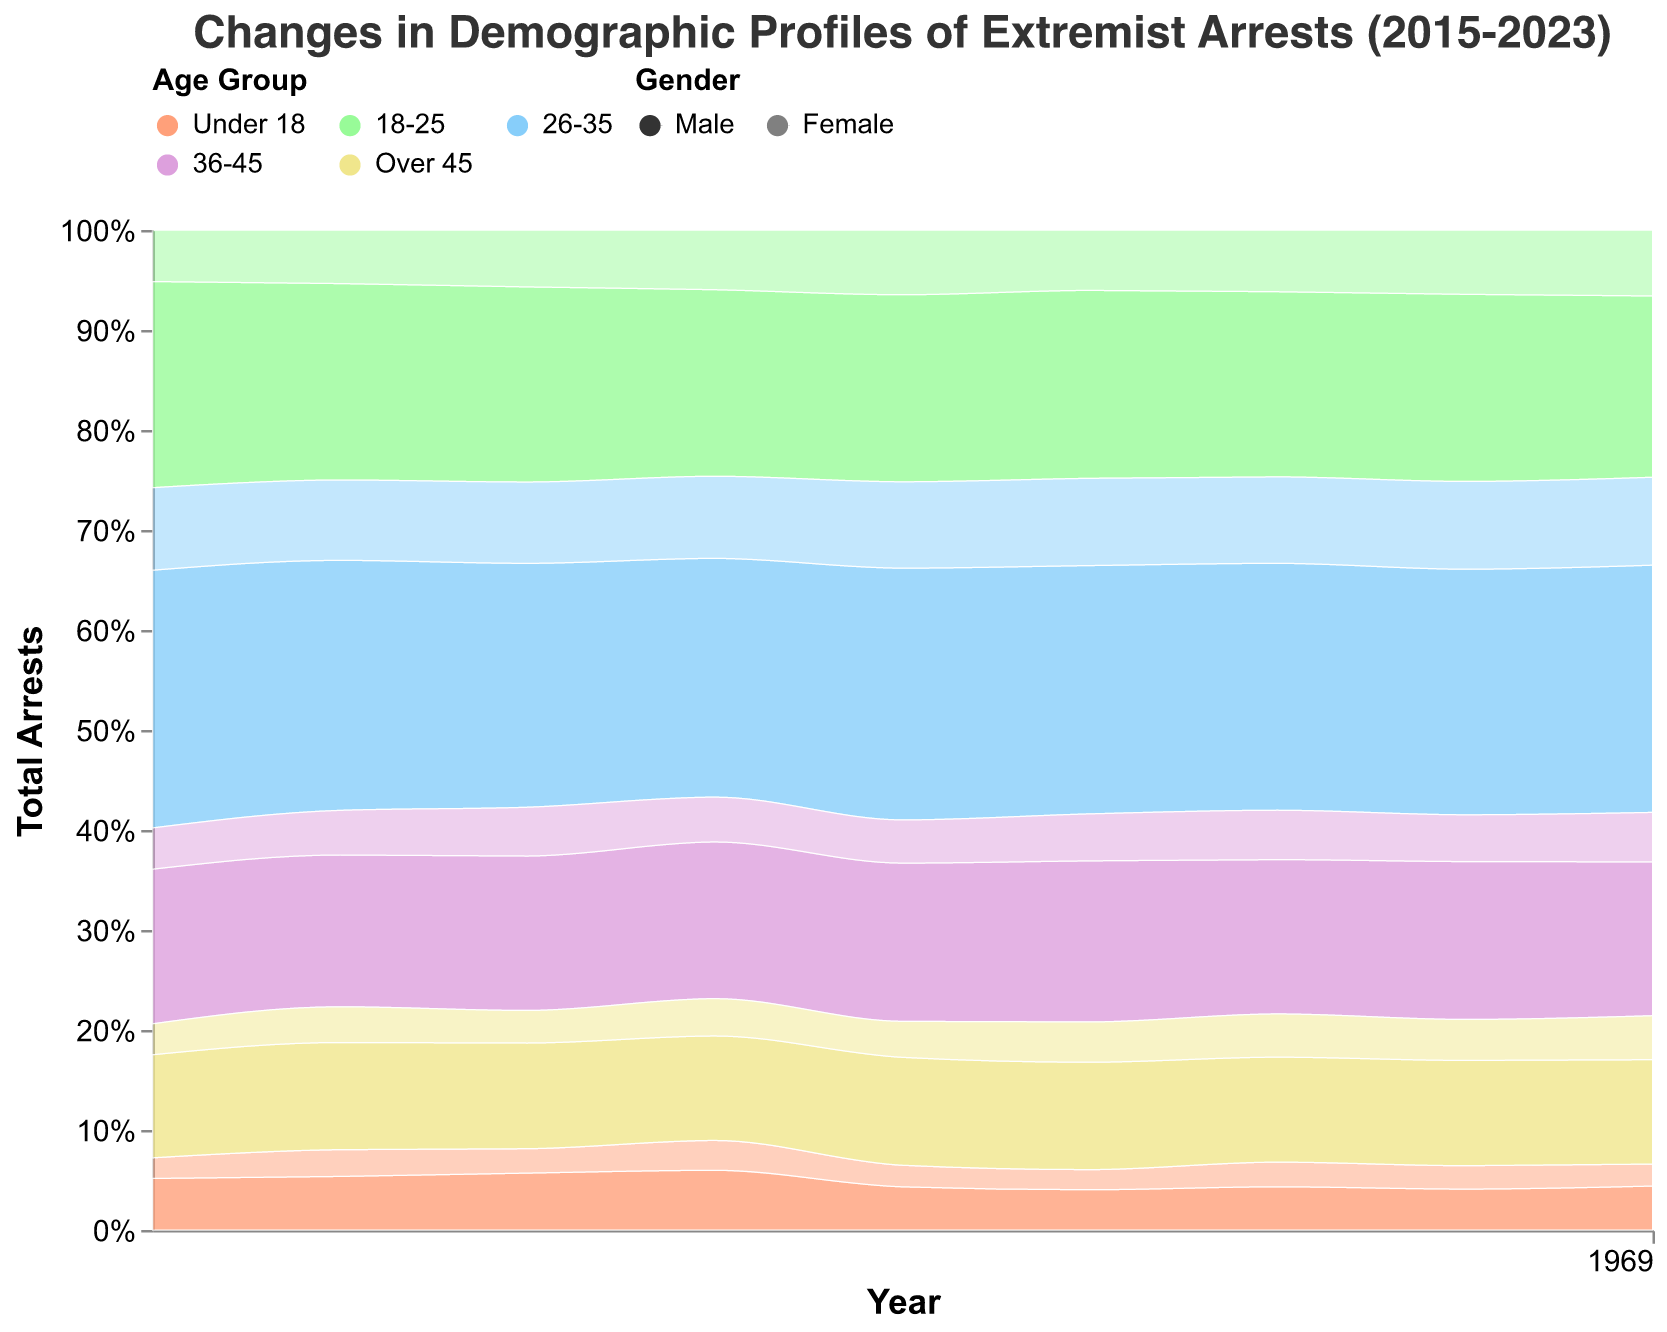What is the trend in the total number of arrests for extremist activities from 2015 to 2023? By observing the height of the areas stacked on each other over the years in the area chart, we can see the total number of arrests generally increasing, with a significant rise from 2019 to 2023.
Answer: Increasing trend Which age group had the highest number of arrests in 2023? By comparing the heights of the colored areas corresponding to each age group in 2023, the "26-35" age group has the highest area, indicating the highest number of arrests.
Answer: 26-35 How has the number of arrests among females aged 26-35 changed from 2015 to 2023? By looking at the portion of the area marked with the 26-35 age group color and lighter opacity (representing females) from 2015 to 2023, there is a clear increase in the number of arrests for this demographic.
Answer: Increased Comparing the gender distribution, which gender had more arrests in 2021 for the 18-25 age group? By observing the height of the areas with different opacities for males and females within the 18-25 age group color in 2021, males had more arrests than females.
Answer: Male Which year shows the highest proportion of arrests for the age group "Under 18"? By observing the height of the "Under 18" colored area relative to the total height in different years, the proportion is highest in 2018.
Answer: 2018 How do the number of arrests for males and females in the "Over 45" age group in 2022 compare? By examining the areas for the "Over 45" age group with different opacities for males and females in 2022, males had more arrests than females.
Answer: Males more than females What general pattern is observed in the age group distribution of extremist arrests from 2015 to 2023? By examining the areas assigned to different age groups over the years, there is a general increase in arrests for younger age groups, particularly the 18-25 and 26-35 categories, indicating a shift towards younger individuals being more involved in extremist activities.
Answer: Increase in younger age groups Which age and gender combination had the lowest number of arrests in 2018? By comparing the areas representing different age and gender combinations in 2018's section, females under 18 had the lowest number of arrests.
Answer: Females under 18 What is the trend in the "36-45" age group's number of arrests from 2015 to 2023? By observing the height of the area marked for the "36-45" age group, the trend shows an overall increase over the years, though the rise is less steep compared to the younger age groups.
Answer: Increasing trend 